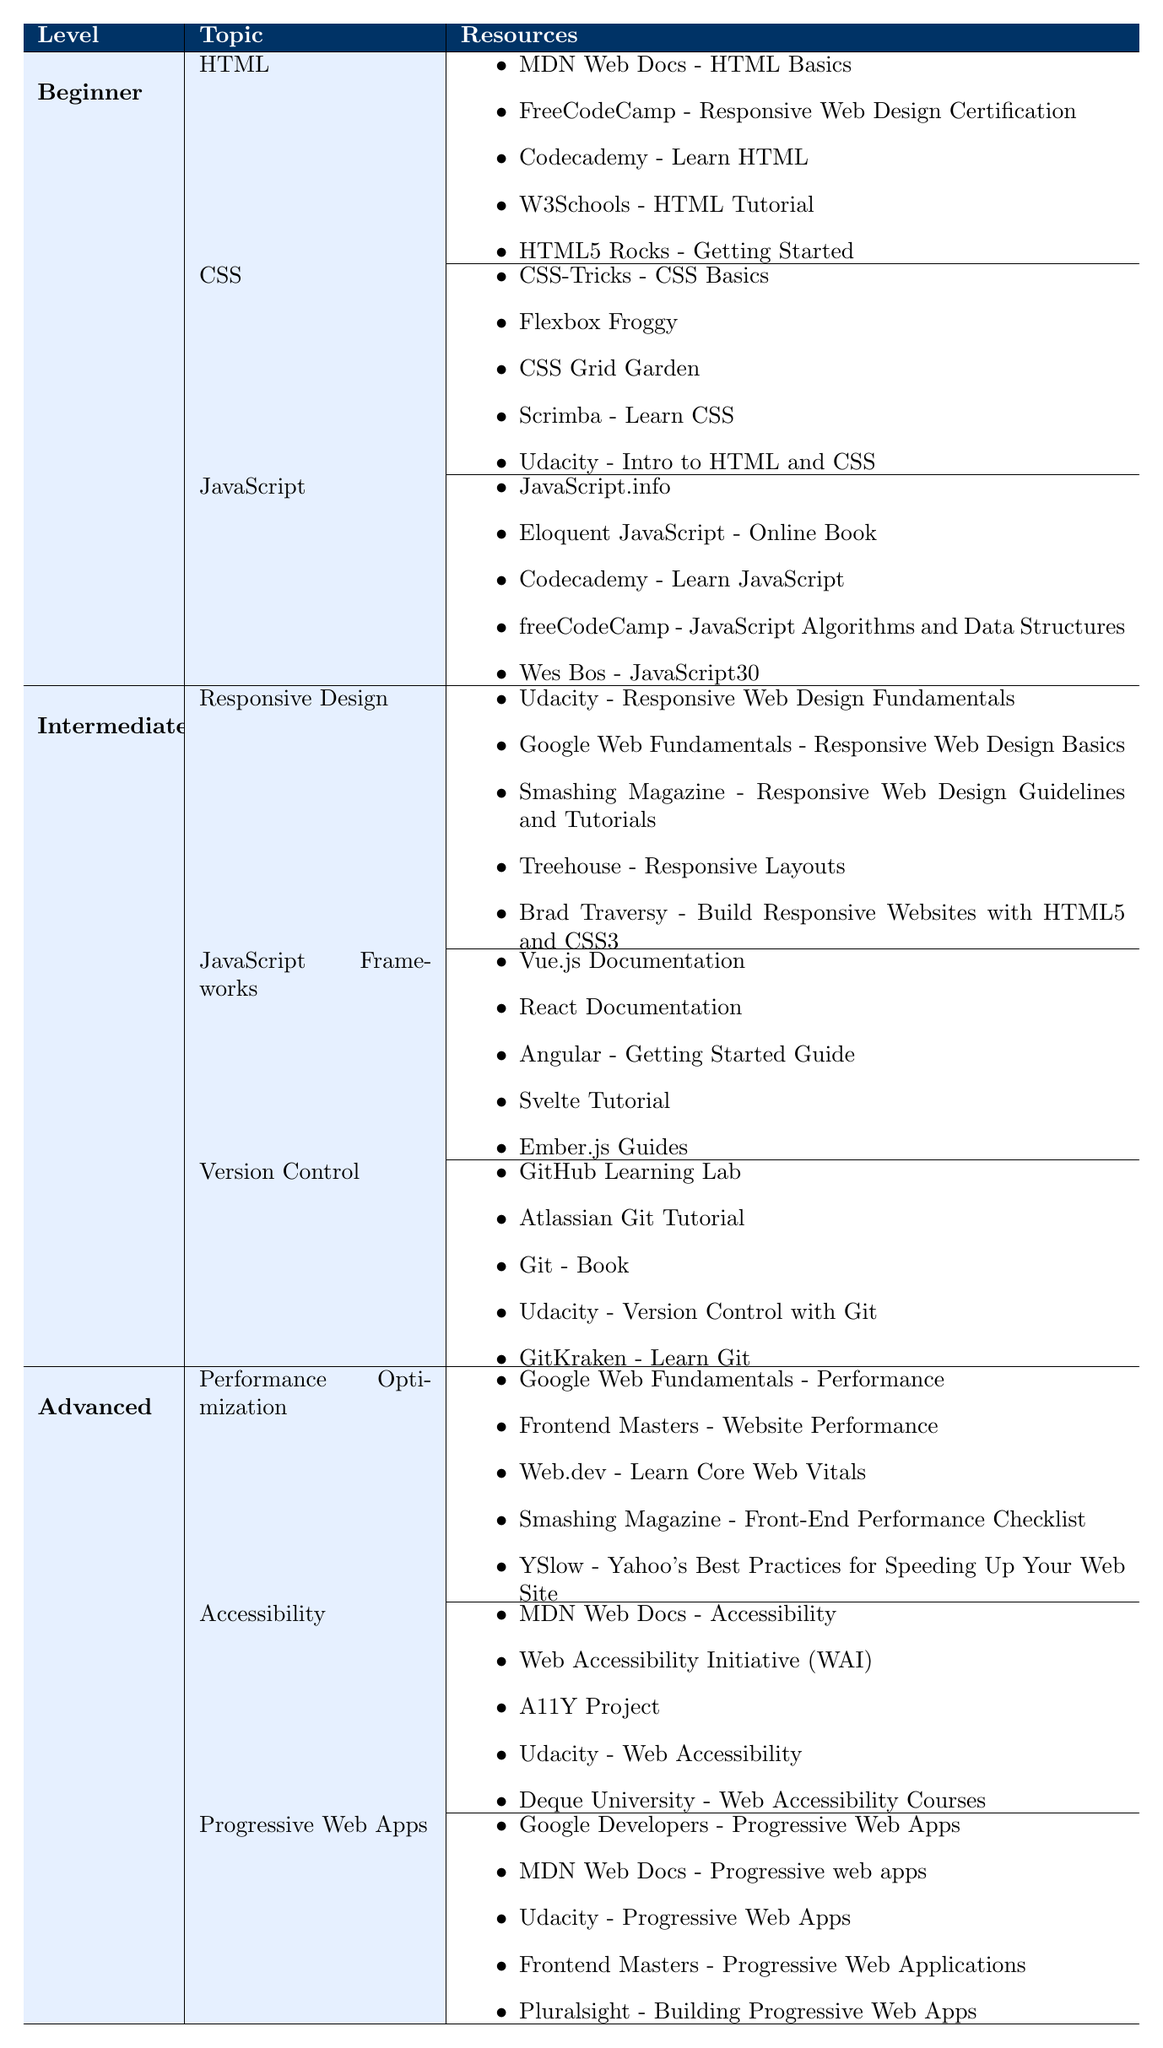What resources are available for beginner CSS learners? Under the Beginner category, the CSS topic lists five resources: CSS-Tricks - CSS Basics, Flexbox Froggy, CSS Grid Garden, Scrimba - Learn CSS, and Udacity - Intro to HTML and CSS.
Answer: CSS-Tricks - CSS Basics, Flexbox Froggy, CSS Grid Garden, Scrimba - Learn CSS, Udacity - Intro to HTML and CSS Which topic has the highest number of resources in the Intermediate category? The Intermediate category features three topics: Responsive Design, JavaScript Frameworks, and Version Control, each with five resources listed, indicating they all have the same amount.
Answer: They all have five resources Is there a resource for Advanced learners focused on accessibility? In the Advanced category, under the Accessibility topic, there are several resources listed, confirming that there is indeed a focus on accessibility.
Answer: Yes How many resources are associated with the Beginner level JavaScript topic? The Beginner level JavaScript topic contains five resources: JavaScript.info, Eloquent JavaScript - Online Book, Codecademy - Learn JavaScript, freeCodeCamp - JavaScript Algorithms and Data Structures, and Wes Bos - JavaScript30.
Answer: Five resources Which has more resources: Intermediate JavaScript Frameworks or Advanced Performance Optimization? Both the Intermediate JavaScript Frameworks and Advanced Performance Optimization topics have five resources each, making them equal in quantity.
Answer: They are equal; both have five resources Are there any resources focused on Progressive Web Apps at the Advanced level? The Advanced category indeed lists a specific topic for Progressive Web Apps, providing several resources under it, confirming their availability.
Answer: Yes What are the total number of accessibility resources available across all skill levels? Under Beginner, Intermediate, and Advanced categories, the only accessibility resources are found in the Advanced category, which has five listed resources. Thus, the total number is five.
Answer: Five resources If we combine the number of resources from Beginner HTML and Beginner CSS topics, how many resources do we have? Beginner HTML has five resources and Beginner CSS also has five resources; adding them gives 5 + 5 = 10.
Answer: Ten resources Does the table indicate that there are more advanced resources related to Performance Optimization than to Accessibility? The Advanced category shows that both Performance Optimization and Accessibility topics each have five resources listed, making them equal.
Answer: No, they are equal Which skill level has the least number of resources listed in a single topic? In the Intermediate level, all three topics (Responsive Design, JavaScript Frameworks, Version Control) contain an equal number of five resources, while the Beginner level does also have five each, but none of them are fewer. Therefore, there isn't a skill level with fewer resources in this context.
Answer: None; every topic has five resources 